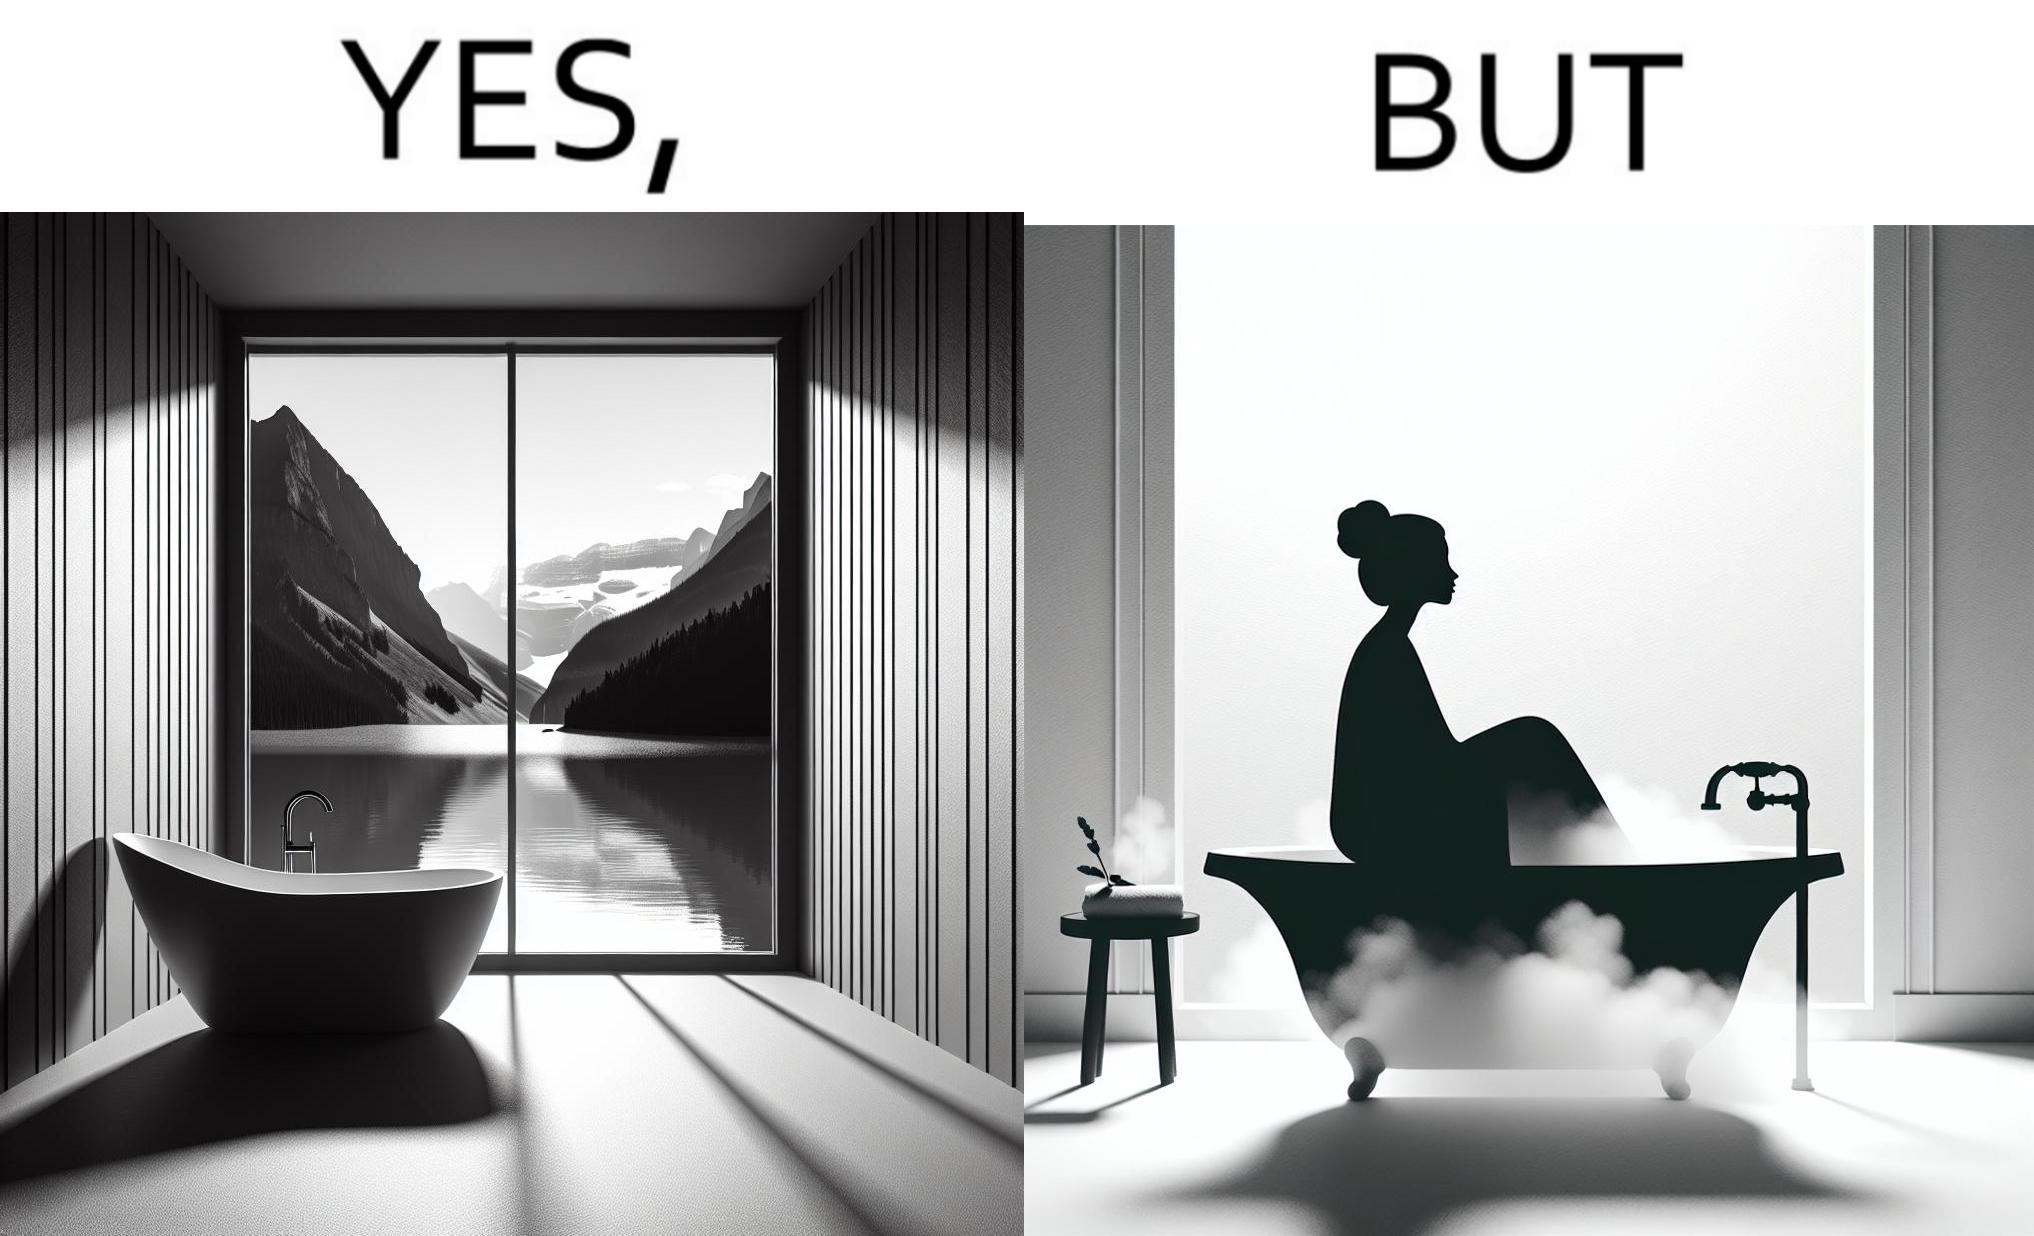Is this image satirical or non-satirical? Yes, this image is satirical. 